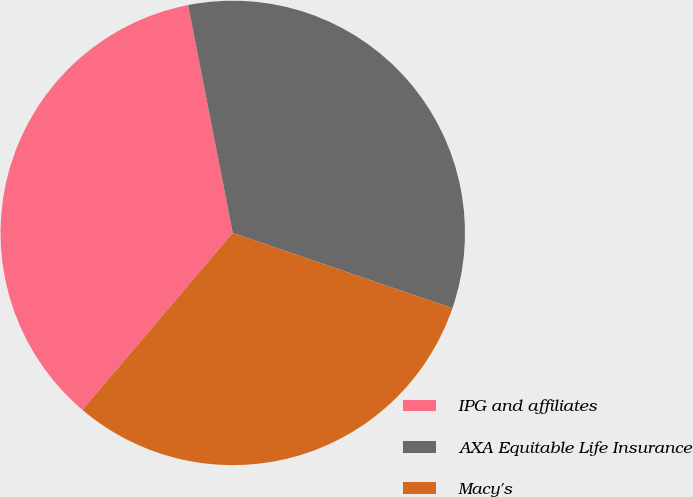Convert chart. <chart><loc_0><loc_0><loc_500><loc_500><pie_chart><fcel>IPG and affiliates<fcel>AXA Equitable Life Insurance<fcel>Macy's<nl><fcel>35.71%<fcel>33.33%<fcel>30.95%<nl></chart> 